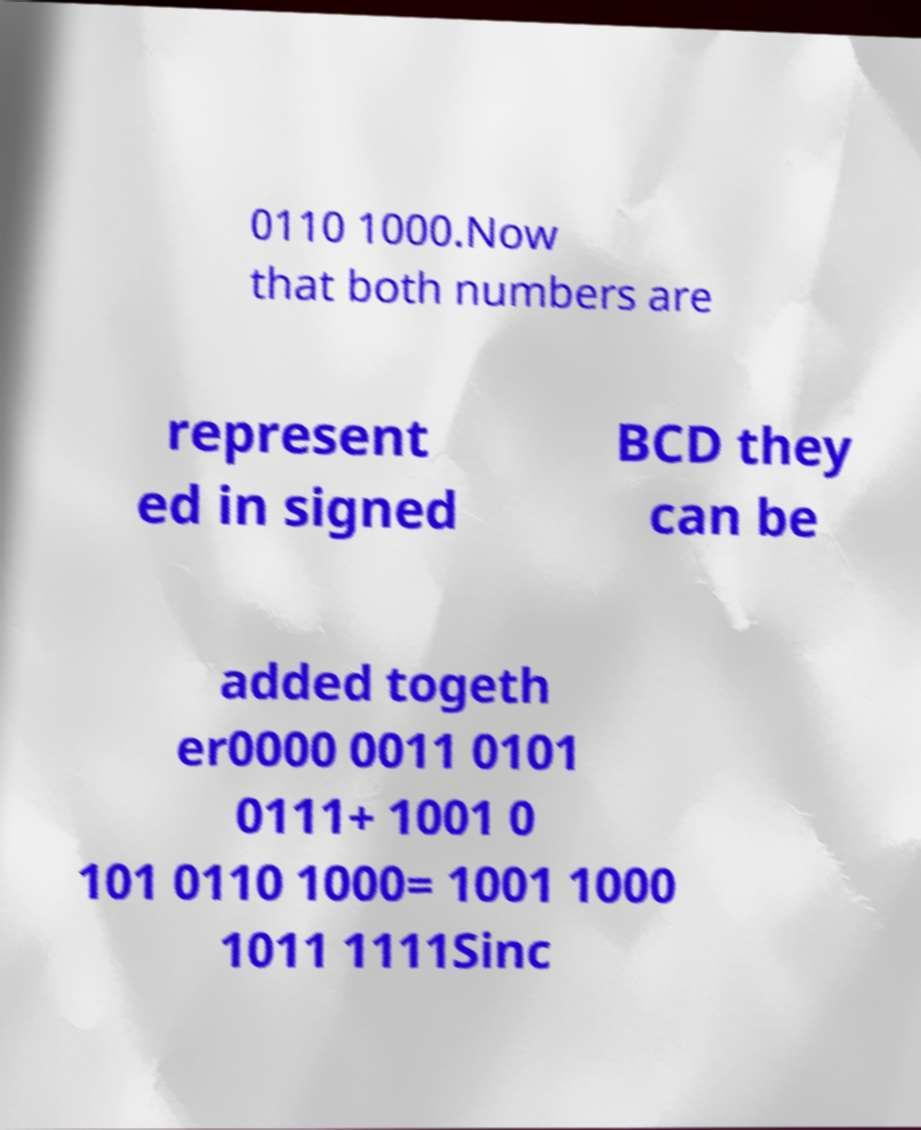What messages or text are displayed in this image? I need them in a readable, typed format. 0110 1000.Now that both numbers are represent ed in signed BCD they can be added togeth er0000 0011 0101 0111+ 1001 0 101 0110 1000= 1001 1000 1011 1111Sinc 